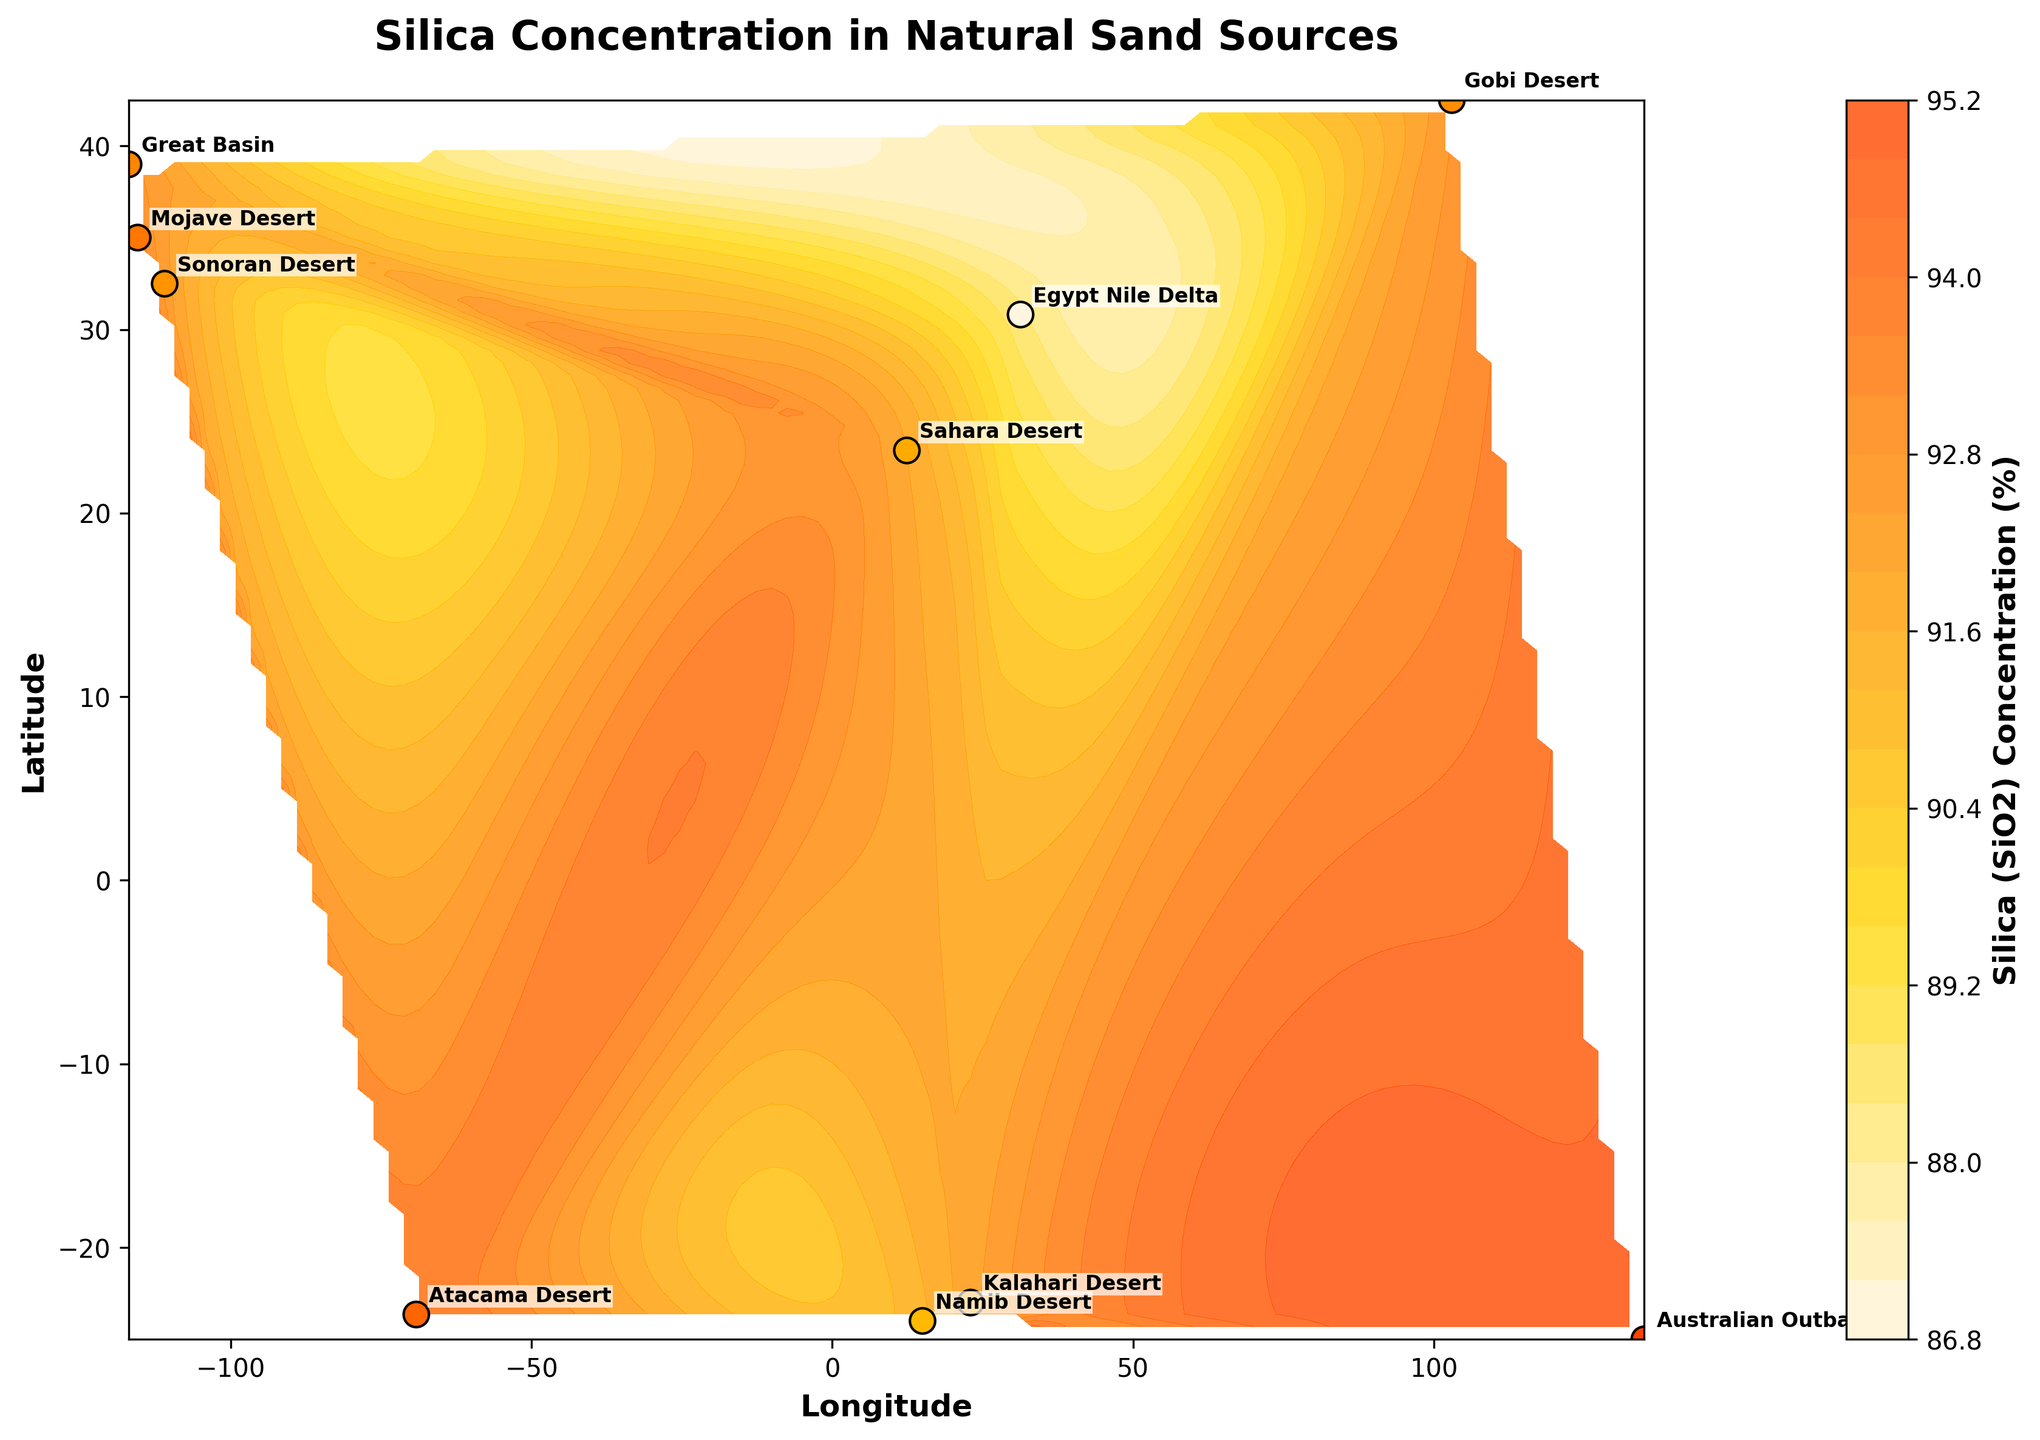What is the title of the contour plot? The title is usually placed at the top of the plot and provides a brief description of what the plot is showing.
Answer: Silica Concentration in Natural Sand Sources What are the x and y axes of the plot labeled? The x and y axes are labeled to indicate the dimensions or variables being plotted. In this case, the labels indicate geographical coordinates.
Answer: Longitude and Latitude How does the color intensity on the plot relate to silica concentration? The color intensity on a contour plot typically represents the magnitude of the variable being visualized. Here, the custom colormap ranges from a light color for low silica concentrations to darker colors for higher concentrations.
Answer: Darker colors represent higher silica concentrations Which sand source has the highest silica concentration and what is the value? To determine this, we look at individual data points and their respective colors or annotations. The scatter plot points will have their silica concentrations and locations labeled.
Answer: Australian Outback with 95.00% Are there any sand sources with silica concentrations below 90%? This requires checking the silica concentrations for each labeled sand source to see if any fall below the 90% threshold. The contour colors will also reflect areas with lower concentrations.
Answer: No What is the approximate silica concentration at longitude 0 and latitude 0? To answer this, find the geographical coordinates (0, 0) on the contour plot and check the contour lines or gradient around that point.
Answer: Approximately 92% Which two sand sources have the closest silica concentrations? To find this, compare the silica concentrations of each sand source and identify the pair with the smallest difference.
Answer: Gobi Desert (92.75%) and Sahara Desert (92.00%) Speaking of the sand sources in North America, which one has a higher silica concentration, the Mojave Desert or the Sonoran Desert? First, identify the locations of the Mojave Desert and the Sonoran Desert on the plot, then compare their silica concentrations.
Answer: Mojave Desert with 93.50% How does the silica concentration vary geographically from the Sahara Desert to the Nile Delta? Check the contour lines or gradient that extends geographically from the Sahara Desert to the Nile Delta to understand the variation in silica concentration.
Answer: The concentration decreases from the Sahara Desert to the Nile Delta What range of silica concentrations does the custom colormap cover? The custom colormap is designed to range from the minimum to the maximum value present in the data. By identifying the lightest and darkest colors on the colorbar, we can infer the range.
Answer: From approximately 88.50% to 95.00% 